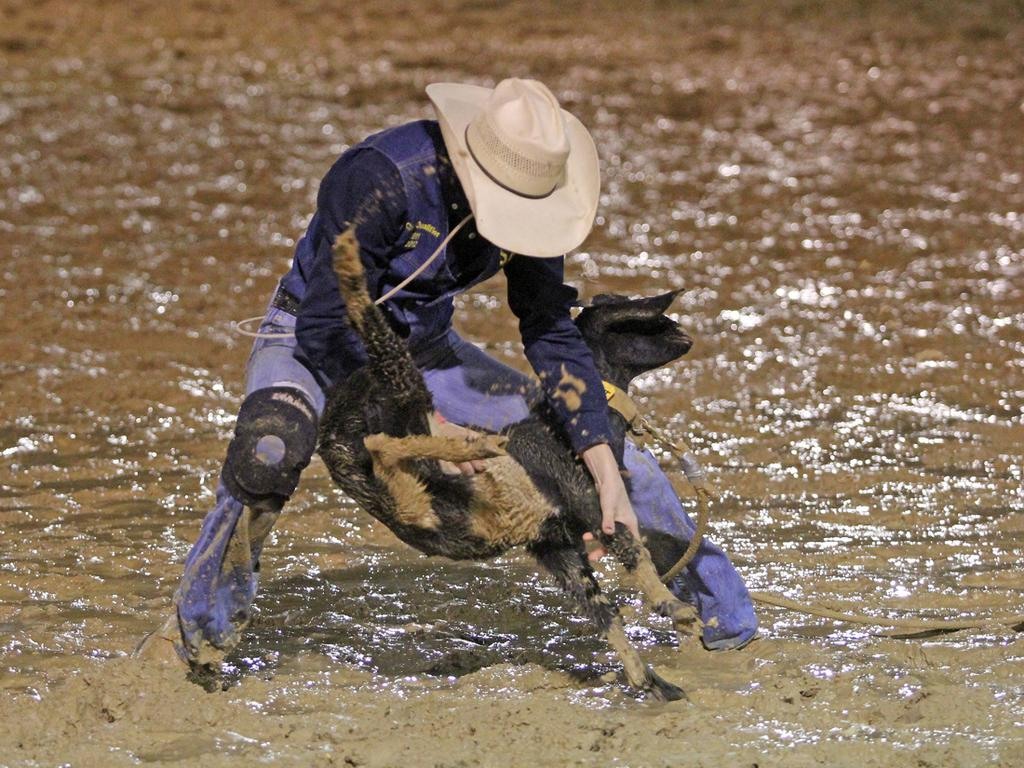What is the condition of the ground in the image? The ground in the image is muddy. Can you describe the person in the image? There is a person in the image, and they are wearing a hat. What is the person holding in the image? The person is holding an animal. What store can be seen in the background of the image? There is no store visible in the image. What caused the ground to become muddy in the image? The facts provided do not indicate the cause of the muddy ground. 